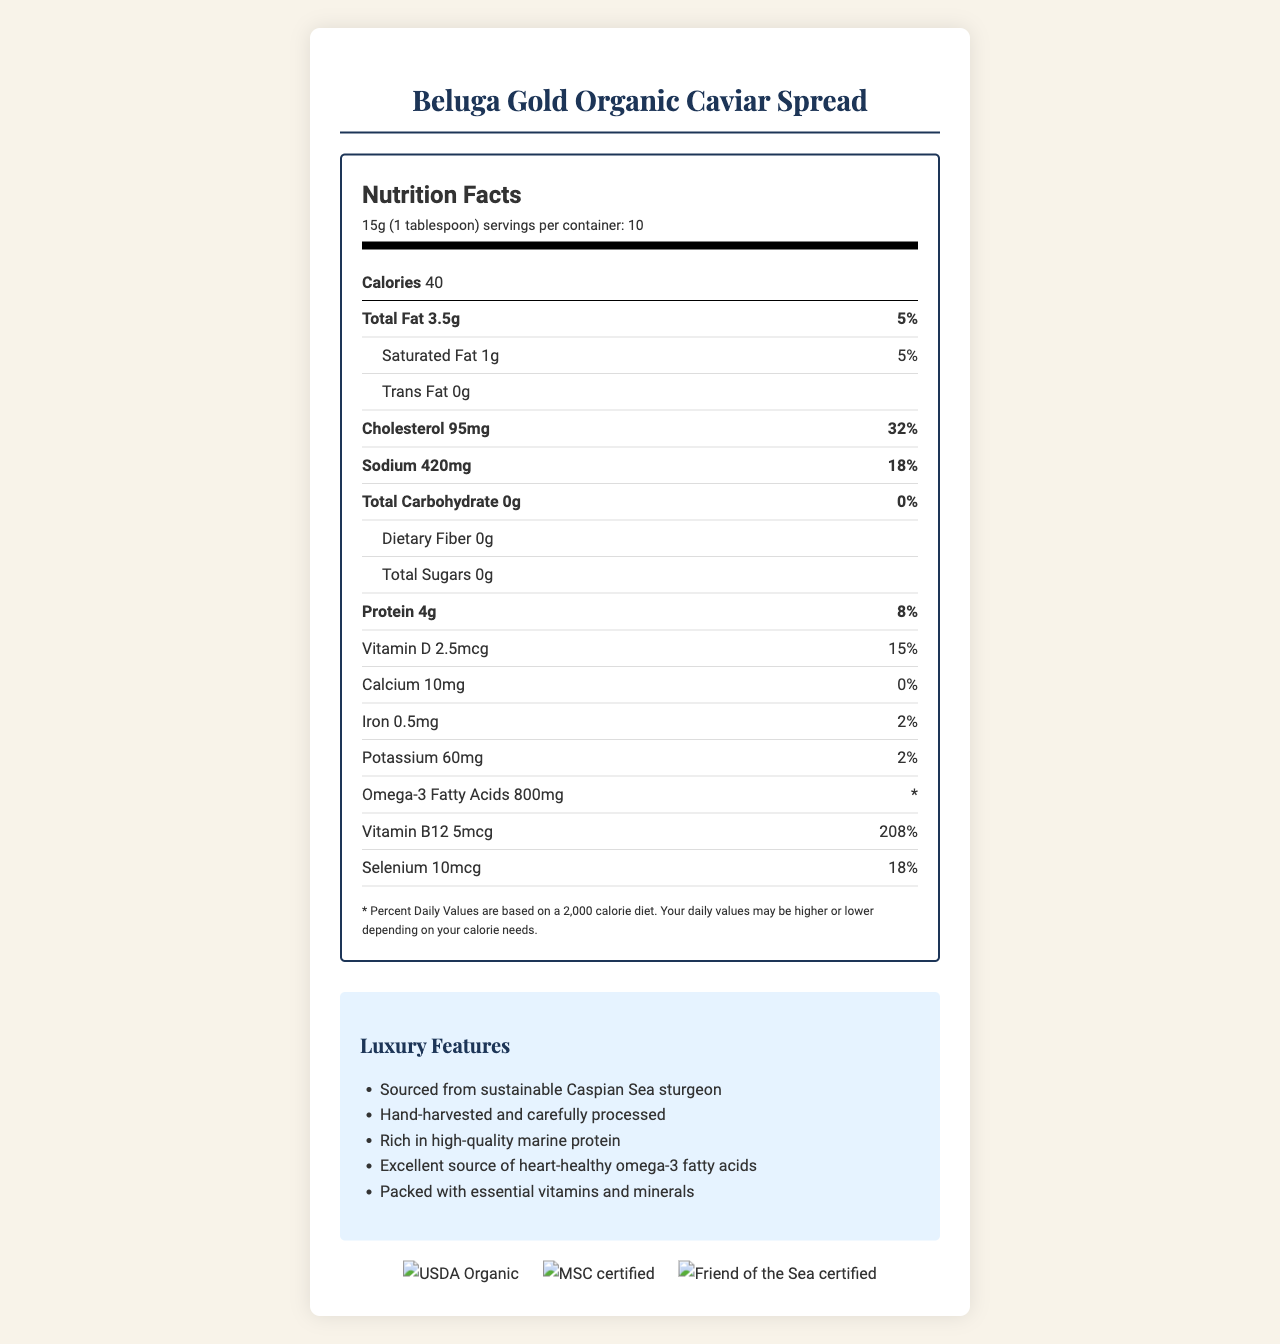what is the serving size? The serving size is specified at the top of the nutrition label as 15g, which is equivalent to 1 tablespoon.
Answer: 15g (1 tablespoon) how many calories are in one serving? The calories per serving are listed just below the serving size information as 40.
Answer: 40 what is the amount of protein in each serving? The protein content for each serving is specified as 4g on the label.
Answer: 4g how much sodium does a single serving contain? The sodium content per serving is indicated on the nutrition label as 420mg.
Answer: 420mg what are the main ingredients of the Beluga Gold Organic Caviar Spread? The main ingredients are listed near the bottom of the document as organic Huso huso caviar, organic extra virgin olive oil, sea salt, organic lemon juice.
Answer: Organic Huso huso caviar, organic extra virgin olive oil, sea salt, organic lemon juice how much omega-3 fatty acid is found in a serving? The document specifies that each serving contains 800mg of omega-3 fatty acids.
Answer: 800mg what certifications does the product have? The certifications are listed towards the end of the document with corresponding logos for USDA Organic, Marine Stewardship Council (MSC), and Friend of the Sea certifications.
Answer: USDA Organic, Marine Stewardship Council (MSC) certified, Friend of the Sea certified how many servings are there per container? The number of servings per container is mentioned at the top of the nutrition label as 10 servings.
Answer: 10 what kind of dietary fiber does the product contain? The nutritional label indicates that the product has 0g of dietary fiber.
Answer: None which vitamin is present in the highest daily value percentage? A. Vitamin D B. Calcium C. Vitamin B12 D. Iron Vitamin B12 is present at 208% daily value, which is the highest among the listed vitamins.
Answer: C how much cholesterol is in one serving? A. 95mg B. 420mg C. 10mg D. 32% The document lists the cholesterol content as 95mg per serving.
Answer: A is there any trans fat in the product? According to the nutrition facts label, the product contains 0g of trans fat.
Answer: No is the document concerned primarily with the luxurious aspects of this product? The document provides detailed nutrition facts and highlights features such as sustainable sourcing and high-quality ingredients, emphasizing the luxurious nature of the product.
Answer: Yes can this document provide information about the price of the caviar spread? The document does not provide any pricing information for the caviar spread. It focuses on nutritional content and luxury features.
Answer: No summarize the main idea of the document. The document includes a nutrition facts section, luxury claims, and certifications, presenting the caviar spread as both a healthy and a premium, sustainably sourced product.
Answer: The document provides a detailed breakdown of the nutritional content of the Beluga Gold Organic Caviar Spread, emphasizing its luxurious ingredients and health benefits, such as high protein and omega-3 fatty acids. It also highlights its sustainable and organic certifications. 